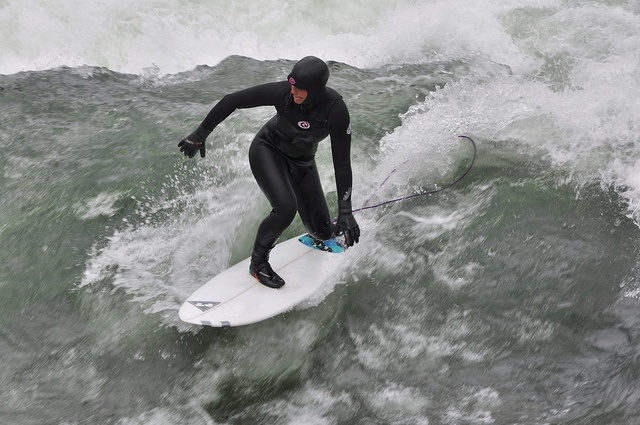Describe the objects in this image and their specific colors. I can see people in lightgray, black, darkgray, and gray tones and surfboard in lightgray, darkgray, and gray tones in this image. 